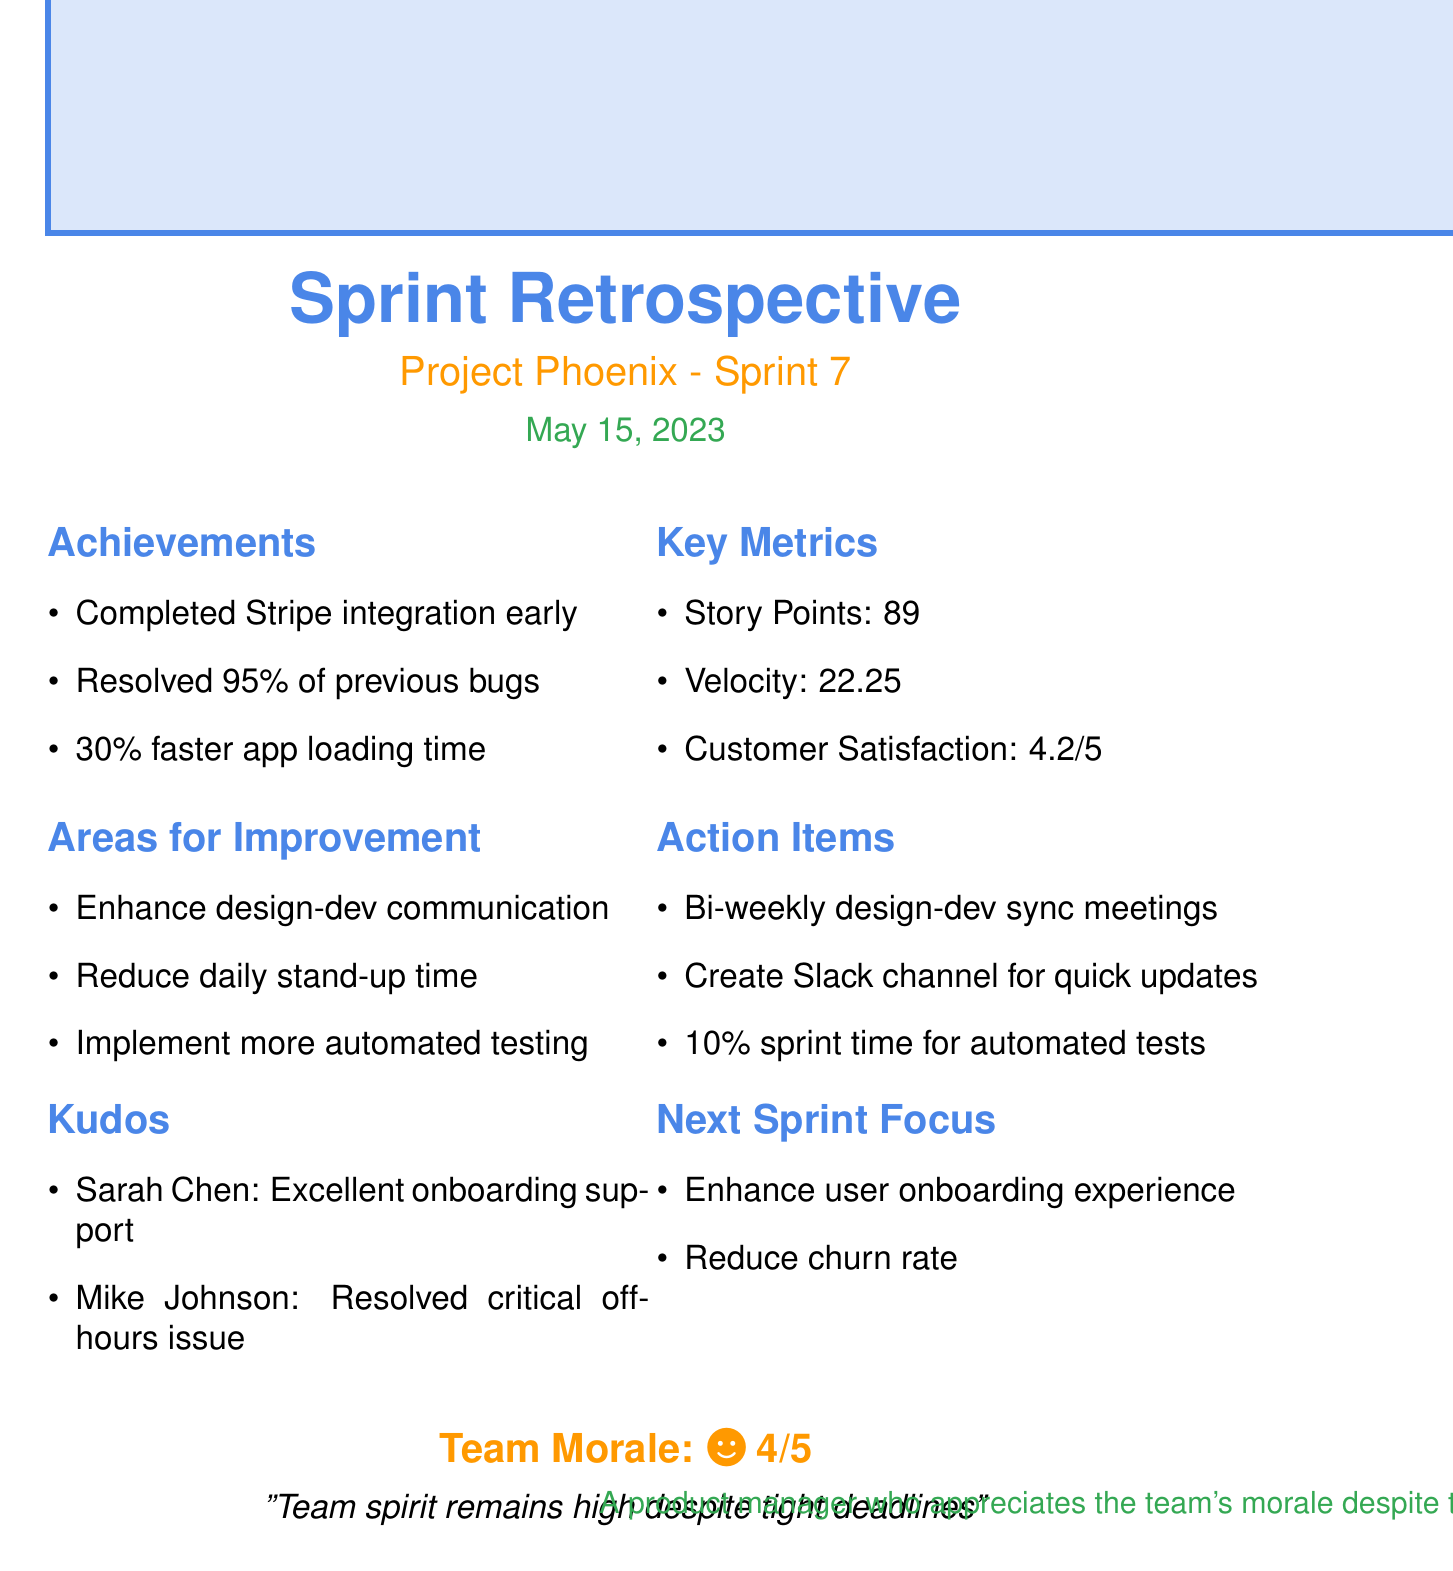What is the date of the sprint retrospective? The date of the sprint retrospective is specifically mentioned in the document as May 15, 2023.
Answer: May 15, 2023 What percentage of reported bugs were resolved in this sprint? The document states that 95% of reported bugs from the previous sprint were resolved.
Answer: 95% Who helped onboard new team members? Sarah Chen is recognized for going above and beyond to help onboard new team members.
Answer: Sarah Chen What is the team morale rating given in the document? The document provides a team morale rating, specifically cited as 4 out of 5.
Answer: 4 What action item addresses communication between teams? The document lists the scheduling of bi-weekly design-dev sync meetings as an action item for improving communication.
Answer: Bi-weekly design-dev sync meetings What is the focus for the next sprint? The upcoming sprint focus includes enhancing user onboarding experience and reducing churn rate, according to the document.
Answer: Enhancing user onboarding experience and reducing churn rate What was the story points completed in this sprint? The document mentions that 89 story points were completed in the current sprint.
Answer: 89 Which team member resolved a critical production issue? Mike Johnson is recognized for resolving a critical production issue during off-hours in the kudos section of the document.
Answer: Mike Johnson 